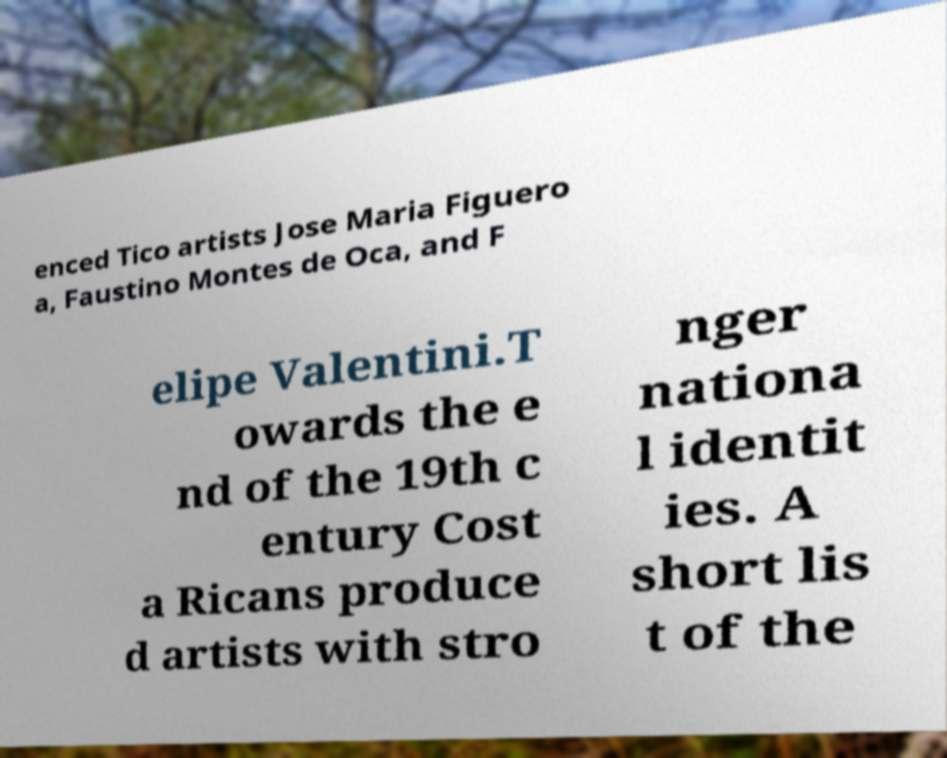For documentation purposes, I need the text within this image transcribed. Could you provide that? enced Tico artists Jose Maria Figuero a, Faustino Montes de Oca, and F elipe Valentini.T owards the e nd of the 19th c entury Cost a Ricans produce d artists with stro nger nationa l identit ies. A short lis t of the 